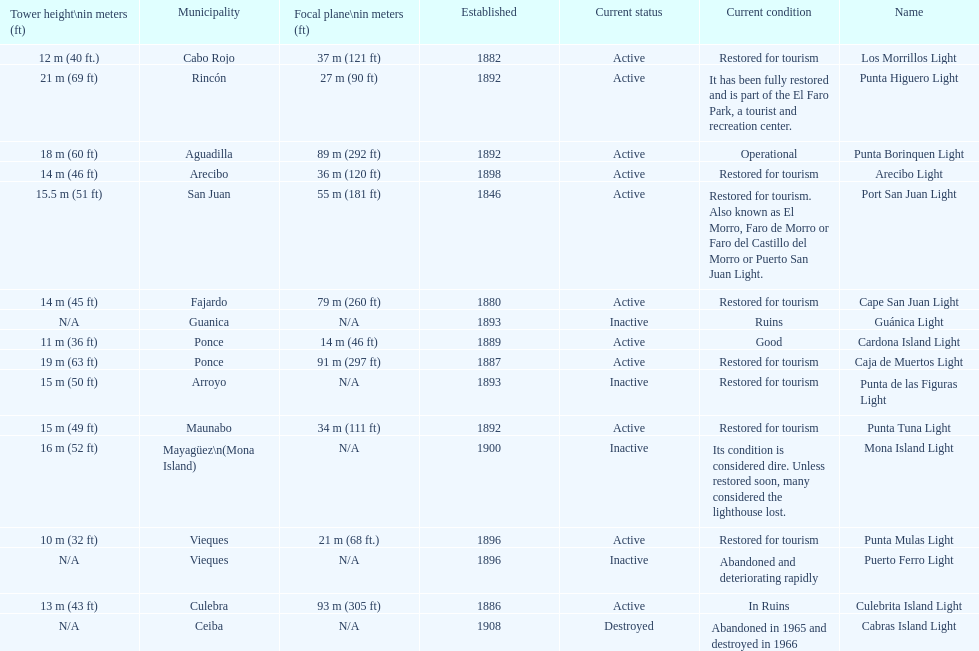What is the largest tower Punta Higuero Light. 